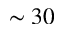Convert formula to latex. <formula><loc_0><loc_0><loc_500><loc_500>\sim 3 0</formula> 